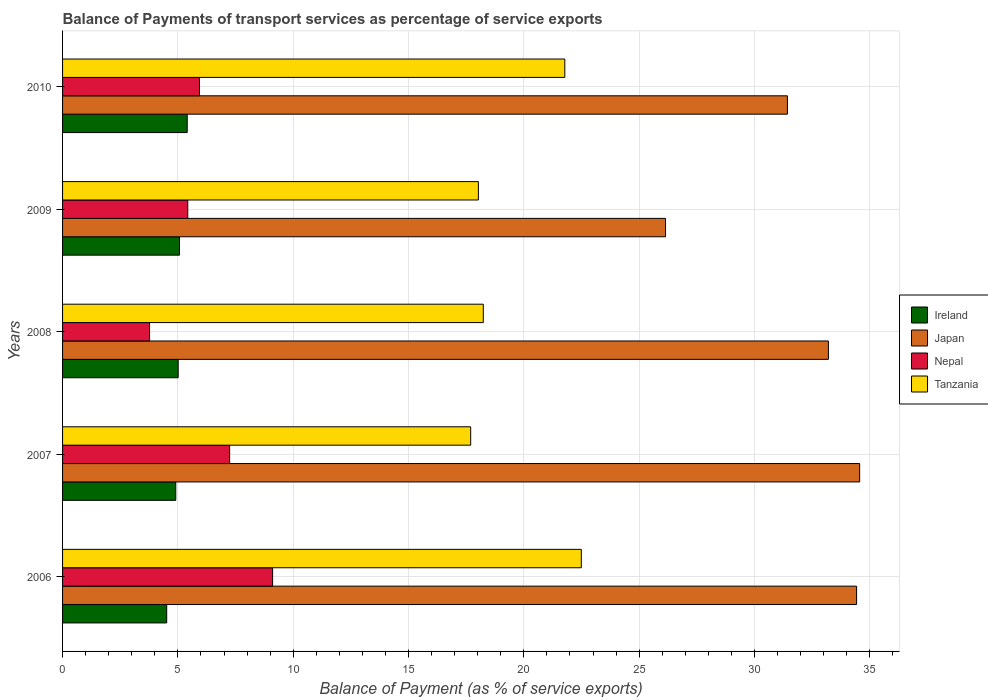How many groups of bars are there?
Make the answer very short. 5. How many bars are there on the 4th tick from the top?
Provide a succinct answer. 4. What is the label of the 1st group of bars from the top?
Ensure brevity in your answer.  2010. In how many cases, is the number of bars for a given year not equal to the number of legend labels?
Your answer should be very brief. 0. What is the balance of payments of transport services in Tanzania in 2010?
Your answer should be very brief. 21.78. Across all years, what is the maximum balance of payments of transport services in Ireland?
Ensure brevity in your answer.  5.4. Across all years, what is the minimum balance of payments of transport services in Ireland?
Your response must be concise. 4.52. In which year was the balance of payments of transport services in Nepal maximum?
Your answer should be compact. 2006. In which year was the balance of payments of transport services in Ireland minimum?
Your answer should be very brief. 2006. What is the total balance of payments of transport services in Ireland in the graph?
Provide a succinct answer. 24.91. What is the difference between the balance of payments of transport services in Ireland in 2007 and that in 2008?
Ensure brevity in your answer.  -0.1. What is the difference between the balance of payments of transport services in Nepal in 2008 and the balance of payments of transport services in Ireland in 2007?
Keep it short and to the point. -1.14. What is the average balance of payments of transport services in Tanzania per year?
Your answer should be compact. 19.65. In the year 2009, what is the difference between the balance of payments of transport services in Ireland and balance of payments of transport services in Tanzania?
Ensure brevity in your answer.  -12.96. In how many years, is the balance of payments of transport services in Japan greater than 13 %?
Keep it short and to the point. 5. What is the ratio of the balance of payments of transport services in Japan in 2006 to that in 2008?
Offer a terse response. 1.04. Is the balance of payments of transport services in Japan in 2007 less than that in 2009?
Make the answer very short. No. What is the difference between the highest and the second highest balance of payments of transport services in Ireland?
Keep it short and to the point. 0.33. What is the difference between the highest and the lowest balance of payments of transport services in Ireland?
Your answer should be very brief. 0.89. In how many years, is the balance of payments of transport services in Japan greater than the average balance of payments of transport services in Japan taken over all years?
Provide a succinct answer. 3. Is it the case that in every year, the sum of the balance of payments of transport services in Nepal and balance of payments of transport services in Japan is greater than the sum of balance of payments of transport services in Tanzania and balance of payments of transport services in Ireland?
Offer a terse response. No. What does the 4th bar from the top in 2007 represents?
Your answer should be compact. Ireland. What does the 2nd bar from the bottom in 2007 represents?
Your answer should be compact. Japan. Is it the case that in every year, the sum of the balance of payments of transport services in Ireland and balance of payments of transport services in Tanzania is greater than the balance of payments of transport services in Nepal?
Keep it short and to the point. Yes. Are all the bars in the graph horizontal?
Offer a very short reply. Yes. How many years are there in the graph?
Keep it short and to the point. 5. Are the values on the major ticks of X-axis written in scientific E-notation?
Offer a very short reply. No. Does the graph contain any zero values?
Your answer should be very brief. No. Does the graph contain grids?
Your answer should be very brief. Yes. Where does the legend appear in the graph?
Your answer should be compact. Center right. How many legend labels are there?
Provide a succinct answer. 4. How are the legend labels stacked?
Keep it short and to the point. Vertical. What is the title of the graph?
Your response must be concise. Balance of Payments of transport services as percentage of service exports. Does "Iraq" appear as one of the legend labels in the graph?
Provide a succinct answer. No. What is the label or title of the X-axis?
Provide a short and direct response. Balance of Payment (as % of service exports). What is the label or title of the Y-axis?
Your answer should be very brief. Years. What is the Balance of Payment (as % of service exports) of Ireland in 2006?
Provide a short and direct response. 4.52. What is the Balance of Payment (as % of service exports) in Japan in 2006?
Keep it short and to the point. 34.43. What is the Balance of Payment (as % of service exports) of Nepal in 2006?
Your response must be concise. 9.11. What is the Balance of Payment (as % of service exports) in Tanzania in 2006?
Your answer should be very brief. 22.49. What is the Balance of Payment (as % of service exports) of Ireland in 2007?
Make the answer very short. 4.91. What is the Balance of Payment (as % of service exports) in Japan in 2007?
Make the answer very short. 34.56. What is the Balance of Payment (as % of service exports) in Nepal in 2007?
Keep it short and to the point. 7.24. What is the Balance of Payment (as % of service exports) in Tanzania in 2007?
Make the answer very short. 17.7. What is the Balance of Payment (as % of service exports) of Ireland in 2008?
Your response must be concise. 5.01. What is the Balance of Payment (as % of service exports) in Japan in 2008?
Your response must be concise. 33.21. What is the Balance of Payment (as % of service exports) in Nepal in 2008?
Your answer should be compact. 3.77. What is the Balance of Payment (as % of service exports) of Tanzania in 2008?
Give a very brief answer. 18.24. What is the Balance of Payment (as % of service exports) of Ireland in 2009?
Your answer should be very brief. 5.07. What is the Balance of Payment (as % of service exports) of Japan in 2009?
Make the answer very short. 26.14. What is the Balance of Payment (as % of service exports) of Nepal in 2009?
Offer a terse response. 5.43. What is the Balance of Payment (as % of service exports) in Tanzania in 2009?
Your answer should be very brief. 18.03. What is the Balance of Payment (as % of service exports) of Ireland in 2010?
Offer a very short reply. 5.4. What is the Balance of Payment (as % of service exports) in Japan in 2010?
Your answer should be compact. 31.43. What is the Balance of Payment (as % of service exports) of Nepal in 2010?
Provide a short and direct response. 5.94. What is the Balance of Payment (as % of service exports) in Tanzania in 2010?
Your answer should be compact. 21.78. Across all years, what is the maximum Balance of Payment (as % of service exports) in Ireland?
Your answer should be compact. 5.4. Across all years, what is the maximum Balance of Payment (as % of service exports) in Japan?
Keep it short and to the point. 34.56. Across all years, what is the maximum Balance of Payment (as % of service exports) of Nepal?
Your response must be concise. 9.11. Across all years, what is the maximum Balance of Payment (as % of service exports) of Tanzania?
Keep it short and to the point. 22.49. Across all years, what is the minimum Balance of Payment (as % of service exports) in Ireland?
Give a very brief answer. 4.52. Across all years, what is the minimum Balance of Payment (as % of service exports) in Japan?
Provide a short and direct response. 26.14. Across all years, what is the minimum Balance of Payment (as % of service exports) in Nepal?
Provide a short and direct response. 3.77. Across all years, what is the minimum Balance of Payment (as % of service exports) in Tanzania?
Provide a short and direct response. 17.7. What is the total Balance of Payment (as % of service exports) in Ireland in the graph?
Offer a terse response. 24.91. What is the total Balance of Payment (as % of service exports) in Japan in the graph?
Offer a terse response. 159.77. What is the total Balance of Payment (as % of service exports) in Nepal in the graph?
Offer a terse response. 31.49. What is the total Balance of Payment (as % of service exports) of Tanzania in the graph?
Offer a terse response. 98.24. What is the difference between the Balance of Payment (as % of service exports) of Ireland in 2006 and that in 2007?
Offer a very short reply. -0.39. What is the difference between the Balance of Payment (as % of service exports) in Japan in 2006 and that in 2007?
Provide a succinct answer. -0.13. What is the difference between the Balance of Payment (as % of service exports) of Nepal in 2006 and that in 2007?
Provide a succinct answer. 1.86. What is the difference between the Balance of Payment (as % of service exports) in Tanzania in 2006 and that in 2007?
Make the answer very short. 4.8. What is the difference between the Balance of Payment (as % of service exports) of Ireland in 2006 and that in 2008?
Your response must be concise. -0.5. What is the difference between the Balance of Payment (as % of service exports) in Japan in 2006 and that in 2008?
Make the answer very short. 1.22. What is the difference between the Balance of Payment (as % of service exports) of Nepal in 2006 and that in 2008?
Give a very brief answer. 5.34. What is the difference between the Balance of Payment (as % of service exports) of Tanzania in 2006 and that in 2008?
Offer a terse response. 4.25. What is the difference between the Balance of Payment (as % of service exports) of Ireland in 2006 and that in 2009?
Give a very brief answer. -0.56. What is the difference between the Balance of Payment (as % of service exports) in Japan in 2006 and that in 2009?
Your answer should be compact. 8.29. What is the difference between the Balance of Payment (as % of service exports) in Nepal in 2006 and that in 2009?
Your response must be concise. 3.68. What is the difference between the Balance of Payment (as % of service exports) of Tanzania in 2006 and that in 2009?
Give a very brief answer. 4.46. What is the difference between the Balance of Payment (as % of service exports) of Ireland in 2006 and that in 2010?
Provide a succinct answer. -0.89. What is the difference between the Balance of Payment (as % of service exports) of Japan in 2006 and that in 2010?
Your answer should be compact. 3. What is the difference between the Balance of Payment (as % of service exports) in Nepal in 2006 and that in 2010?
Provide a succinct answer. 3.17. What is the difference between the Balance of Payment (as % of service exports) in Tanzania in 2006 and that in 2010?
Provide a succinct answer. 0.72. What is the difference between the Balance of Payment (as % of service exports) of Ireland in 2007 and that in 2008?
Your response must be concise. -0.1. What is the difference between the Balance of Payment (as % of service exports) of Japan in 2007 and that in 2008?
Ensure brevity in your answer.  1.36. What is the difference between the Balance of Payment (as % of service exports) of Nepal in 2007 and that in 2008?
Make the answer very short. 3.47. What is the difference between the Balance of Payment (as % of service exports) in Tanzania in 2007 and that in 2008?
Make the answer very short. -0.55. What is the difference between the Balance of Payment (as % of service exports) in Ireland in 2007 and that in 2009?
Offer a very short reply. -0.16. What is the difference between the Balance of Payment (as % of service exports) in Japan in 2007 and that in 2009?
Your response must be concise. 8.42. What is the difference between the Balance of Payment (as % of service exports) of Nepal in 2007 and that in 2009?
Your answer should be very brief. 1.82. What is the difference between the Balance of Payment (as % of service exports) in Tanzania in 2007 and that in 2009?
Provide a short and direct response. -0.33. What is the difference between the Balance of Payment (as % of service exports) of Ireland in 2007 and that in 2010?
Keep it short and to the point. -0.5. What is the difference between the Balance of Payment (as % of service exports) of Japan in 2007 and that in 2010?
Your answer should be compact. 3.13. What is the difference between the Balance of Payment (as % of service exports) of Nepal in 2007 and that in 2010?
Provide a succinct answer. 1.31. What is the difference between the Balance of Payment (as % of service exports) of Tanzania in 2007 and that in 2010?
Provide a short and direct response. -4.08. What is the difference between the Balance of Payment (as % of service exports) in Ireland in 2008 and that in 2009?
Keep it short and to the point. -0.06. What is the difference between the Balance of Payment (as % of service exports) of Japan in 2008 and that in 2009?
Offer a very short reply. 7.06. What is the difference between the Balance of Payment (as % of service exports) of Nepal in 2008 and that in 2009?
Give a very brief answer. -1.66. What is the difference between the Balance of Payment (as % of service exports) in Tanzania in 2008 and that in 2009?
Ensure brevity in your answer.  0.21. What is the difference between the Balance of Payment (as % of service exports) of Ireland in 2008 and that in 2010?
Offer a terse response. -0.39. What is the difference between the Balance of Payment (as % of service exports) in Japan in 2008 and that in 2010?
Your answer should be compact. 1.78. What is the difference between the Balance of Payment (as % of service exports) in Nepal in 2008 and that in 2010?
Your answer should be very brief. -2.16. What is the difference between the Balance of Payment (as % of service exports) in Tanzania in 2008 and that in 2010?
Your answer should be very brief. -3.53. What is the difference between the Balance of Payment (as % of service exports) of Ireland in 2009 and that in 2010?
Your answer should be very brief. -0.33. What is the difference between the Balance of Payment (as % of service exports) of Japan in 2009 and that in 2010?
Keep it short and to the point. -5.29. What is the difference between the Balance of Payment (as % of service exports) of Nepal in 2009 and that in 2010?
Make the answer very short. -0.51. What is the difference between the Balance of Payment (as % of service exports) in Tanzania in 2009 and that in 2010?
Provide a succinct answer. -3.75. What is the difference between the Balance of Payment (as % of service exports) in Ireland in 2006 and the Balance of Payment (as % of service exports) in Japan in 2007?
Your answer should be very brief. -30.05. What is the difference between the Balance of Payment (as % of service exports) in Ireland in 2006 and the Balance of Payment (as % of service exports) in Nepal in 2007?
Give a very brief answer. -2.73. What is the difference between the Balance of Payment (as % of service exports) of Ireland in 2006 and the Balance of Payment (as % of service exports) of Tanzania in 2007?
Your answer should be compact. -13.18. What is the difference between the Balance of Payment (as % of service exports) of Japan in 2006 and the Balance of Payment (as % of service exports) of Nepal in 2007?
Make the answer very short. 27.19. What is the difference between the Balance of Payment (as % of service exports) of Japan in 2006 and the Balance of Payment (as % of service exports) of Tanzania in 2007?
Offer a very short reply. 16.73. What is the difference between the Balance of Payment (as % of service exports) in Nepal in 2006 and the Balance of Payment (as % of service exports) in Tanzania in 2007?
Offer a very short reply. -8.59. What is the difference between the Balance of Payment (as % of service exports) of Ireland in 2006 and the Balance of Payment (as % of service exports) of Japan in 2008?
Offer a terse response. -28.69. What is the difference between the Balance of Payment (as % of service exports) in Ireland in 2006 and the Balance of Payment (as % of service exports) in Nepal in 2008?
Ensure brevity in your answer.  0.74. What is the difference between the Balance of Payment (as % of service exports) in Ireland in 2006 and the Balance of Payment (as % of service exports) in Tanzania in 2008?
Ensure brevity in your answer.  -13.73. What is the difference between the Balance of Payment (as % of service exports) in Japan in 2006 and the Balance of Payment (as % of service exports) in Nepal in 2008?
Keep it short and to the point. 30.66. What is the difference between the Balance of Payment (as % of service exports) of Japan in 2006 and the Balance of Payment (as % of service exports) of Tanzania in 2008?
Make the answer very short. 16.19. What is the difference between the Balance of Payment (as % of service exports) in Nepal in 2006 and the Balance of Payment (as % of service exports) in Tanzania in 2008?
Your answer should be very brief. -9.13. What is the difference between the Balance of Payment (as % of service exports) in Ireland in 2006 and the Balance of Payment (as % of service exports) in Japan in 2009?
Keep it short and to the point. -21.63. What is the difference between the Balance of Payment (as % of service exports) of Ireland in 2006 and the Balance of Payment (as % of service exports) of Nepal in 2009?
Your answer should be compact. -0.91. What is the difference between the Balance of Payment (as % of service exports) in Ireland in 2006 and the Balance of Payment (as % of service exports) in Tanzania in 2009?
Keep it short and to the point. -13.52. What is the difference between the Balance of Payment (as % of service exports) in Japan in 2006 and the Balance of Payment (as % of service exports) in Nepal in 2009?
Make the answer very short. 29. What is the difference between the Balance of Payment (as % of service exports) in Japan in 2006 and the Balance of Payment (as % of service exports) in Tanzania in 2009?
Give a very brief answer. 16.4. What is the difference between the Balance of Payment (as % of service exports) in Nepal in 2006 and the Balance of Payment (as % of service exports) in Tanzania in 2009?
Ensure brevity in your answer.  -8.92. What is the difference between the Balance of Payment (as % of service exports) of Ireland in 2006 and the Balance of Payment (as % of service exports) of Japan in 2010?
Offer a very short reply. -26.92. What is the difference between the Balance of Payment (as % of service exports) in Ireland in 2006 and the Balance of Payment (as % of service exports) in Nepal in 2010?
Ensure brevity in your answer.  -1.42. What is the difference between the Balance of Payment (as % of service exports) in Ireland in 2006 and the Balance of Payment (as % of service exports) in Tanzania in 2010?
Give a very brief answer. -17.26. What is the difference between the Balance of Payment (as % of service exports) of Japan in 2006 and the Balance of Payment (as % of service exports) of Nepal in 2010?
Ensure brevity in your answer.  28.49. What is the difference between the Balance of Payment (as % of service exports) of Japan in 2006 and the Balance of Payment (as % of service exports) of Tanzania in 2010?
Provide a short and direct response. 12.65. What is the difference between the Balance of Payment (as % of service exports) of Nepal in 2006 and the Balance of Payment (as % of service exports) of Tanzania in 2010?
Your answer should be compact. -12.67. What is the difference between the Balance of Payment (as % of service exports) in Ireland in 2007 and the Balance of Payment (as % of service exports) in Japan in 2008?
Offer a very short reply. -28.3. What is the difference between the Balance of Payment (as % of service exports) of Ireland in 2007 and the Balance of Payment (as % of service exports) of Nepal in 2008?
Offer a very short reply. 1.14. What is the difference between the Balance of Payment (as % of service exports) of Ireland in 2007 and the Balance of Payment (as % of service exports) of Tanzania in 2008?
Your answer should be compact. -13.33. What is the difference between the Balance of Payment (as % of service exports) in Japan in 2007 and the Balance of Payment (as % of service exports) in Nepal in 2008?
Your response must be concise. 30.79. What is the difference between the Balance of Payment (as % of service exports) in Japan in 2007 and the Balance of Payment (as % of service exports) in Tanzania in 2008?
Offer a very short reply. 16.32. What is the difference between the Balance of Payment (as % of service exports) in Nepal in 2007 and the Balance of Payment (as % of service exports) in Tanzania in 2008?
Offer a terse response. -11. What is the difference between the Balance of Payment (as % of service exports) in Ireland in 2007 and the Balance of Payment (as % of service exports) in Japan in 2009?
Offer a terse response. -21.24. What is the difference between the Balance of Payment (as % of service exports) of Ireland in 2007 and the Balance of Payment (as % of service exports) of Nepal in 2009?
Give a very brief answer. -0.52. What is the difference between the Balance of Payment (as % of service exports) in Ireland in 2007 and the Balance of Payment (as % of service exports) in Tanzania in 2009?
Make the answer very short. -13.12. What is the difference between the Balance of Payment (as % of service exports) in Japan in 2007 and the Balance of Payment (as % of service exports) in Nepal in 2009?
Give a very brief answer. 29.13. What is the difference between the Balance of Payment (as % of service exports) in Japan in 2007 and the Balance of Payment (as % of service exports) in Tanzania in 2009?
Provide a short and direct response. 16.53. What is the difference between the Balance of Payment (as % of service exports) of Nepal in 2007 and the Balance of Payment (as % of service exports) of Tanzania in 2009?
Provide a short and direct response. -10.79. What is the difference between the Balance of Payment (as % of service exports) in Ireland in 2007 and the Balance of Payment (as % of service exports) in Japan in 2010?
Ensure brevity in your answer.  -26.52. What is the difference between the Balance of Payment (as % of service exports) of Ireland in 2007 and the Balance of Payment (as % of service exports) of Nepal in 2010?
Offer a terse response. -1.03. What is the difference between the Balance of Payment (as % of service exports) of Ireland in 2007 and the Balance of Payment (as % of service exports) of Tanzania in 2010?
Make the answer very short. -16.87. What is the difference between the Balance of Payment (as % of service exports) in Japan in 2007 and the Balance of Payment (as % of service exports) in Nepal in 2010?
Your answer should be compact. 28.63. What is the difference between the Balance of Payment (as % of service exports) of Japan in 2007 and the Balance of Payment (as % of service exports) of Tanzania in 2010?
Your response must be concise. 12.78. What is the difference between the Balance of Payment (as % of service exports) of Nepal in 2007 and the Balance of Payment (as % of service exports) of Tanzania in 2010?
Your response must be concise. -14.53. What is the difference between the Balance of Payment (as % of service exports) in Ireland in 2008 and the Balance of Payment (as % of service exports) in Japan in 2009?
Your answer should be very brief. -21.13. What is the difference between the Balance of Payment (as % of service exports) of Ireland in 2008 and the Balance of Payment (as % of service exports) of Nepal in 2009?
Your answer should be very brief. -0.42. What is the difference between the Balance of Payment (as % of service exports) of Ireland in 2008 and the Balance of Payment (as % of service exports) of Tanzania in 2009?
Provide a short and direct response. -13.02. What is the difference between the Balance of Payment (as % of service exports) in Japan in 2008 and the Balance of Payment (as % of service exports) in Nepal in 2009?
Your answer should be very brief. 27.78. What is the difference between the Balance of Payment (as % of service exports) in Japan in 2008 and the Balance of Payment (as % of service exports) in Tanzania in 2009?
Ensure brevity in your answer.  15.18. What is the difference between the Balance of Payment (as % of service exports) of Nepal in 2008 and the Balance of Payment (as % of service exports) of Tanzania in 2009?
Make the answer very short. -14.26. What is the difference between the Balance of Payment (as % of service exports) in Ireland in 2008 and the Balance of Payment (as % of service exports) in Japan in 2010?
Offer a very short reply. -26.42. What is the difference between the Balance of Payment (as % of service exports) in Ireland in 2008 and the Balance of Payment (as % of service exports) in Nepal in 2010?
Ensure brevity in your answer.  -0.92. What is the difference between the Balance of Payment (as % of service exports) of Ireland in 2008 and the Balance of Payment (as % of service exports) of Tanzania in 2010?
Ensure brevity in your answer.  -16.77. What is the difference between the Balance of Payment (as % of service exports) of Japan in 2008 and the Balance of Payment (as % of service exports) of Nepal in 2010?
Keep it short and to the point. 27.27. What is the difference between the Balance of Payment (as % of service exports) of Japan in 2008 and the Balance of Payment (as % of service exports) of Tanzania in 2010?
Provide a succinct answer. 11.43. What is the difference between the Balance of Payment (as % of service exports) of Nepal in 2008 and the Balance of Payment (as % of service exports) of Tanzania in 2010?
Make the answer very short. -18.01. What is the difference between the Balance of Payment (as % of service exports) in Ireland in 2009 and the Balance of Payment (as % of service exports) in Japan in 2010?
Give a very brief answer. -26.36. What is the difference between the Balance of Payment (as % of service exports) of Ireland in 2009 and the Balance of Payment (as % of service exports) of Nepal in 2010?
Ensure brevity in your answer.  -0.87. What is the difference between the Balance of Payment (as % of service exports) in Ireland in 2009 and the Balance of Payment (as % of service exports) in Tanzania in 2010?
Your response must be concise. -16.71. What is the difference between the Balance of Payment (as % of service exports) in Japan in 2009 and the Balance of Payment (as % of service exports) in Nepal in 2010?
Offer a terse response. 20.21. What is the difference between the Balance of Payment (as % of service exports) of Japan in 2009 and the Balance of Payment (as % of service exports) of Tanzania in 2010?
Your answer should be very brief. 4.37. What is the difference between the Balance of Payment (as % of service exports) in Nepal in 2009 and the Balance of Payment (as % of service exports) in Tanzania in 2010?
Your answer should be very brief. -16.35. What is the average Balance of Payment (as % of service exports) of Ireland per year?
Your response must be concise. 4.98. What is the average Balance of Payment (as % of service exports) of Japan per year?
Make the answer very short. 31.95. What is the average Balance of Payment (as % of service exports) of Nepal per year?
Make the answer very short. 6.3. What is the average Balance of Payment (as % of service exports) of Tanzania per year?
Provide a succinct answer. 19.65. In the year 2006, what is the difference between the Balance of Payment (as % of service exports) in Ireland and Balance of Payment (as % of service exports) in Japan?
Your answer should be compact. -29.91. In the year 2006, what is the difference between the Balance of Payment (as % of service exports) in Ireland and Balance of Payment (as % of service exports) in Nepal?
Your answer should be compact. -4.59. In the year 2006, what is the difference between the Balance of Payment (as % of service exports) in Ireland and Balance of Payment (as % of service exports) in Tanzania?
Give a very brief answer. -17.98. In the year 2006, what is the difference between the Balance of Payment (as % of service exports) of Japan and Balance of Payment (as % of service exports) of Nepal?
Offer a terse response. 25.32. In the year 2006, what is the difference between the Balance of Payment (as % of service exports) of Japan and Balance of Payment (as % of service exports) of Tanzania?
Offer a very short reply. 11.94. In the year 2006, what is the difference between the Balance of Payment (as % of service exports) in Nepal and Balance of Payment (as % of service exports) in Tanzania?
Your response must be concise. -13.39. In the year 2007, what is the difference between the Balance of Payment (as % of service exports) of Ireland and Balance of Payment (as % of service exports) of Japan?
Your answer should be very brief. -29.65. In the year 2007, what is the difference between the Balance of Payment (as % of service exports) of Ireland and Balance of Payment (as % of service exports) of Nepal?
Your answer should be very brief. -2.34. In the year 2007, what is the difference between the Balance of Payment (as % of service exports) of Ireland and Balance of Payment (as % of service exports) of Tanzania?
Offer a very short reply. -12.79. In the year 2007, what is the difference between the Balance of Payment (as % of service exports) in Japan and Balance of Payment (as % of service exports) in Nepal?
Offer a terse response. 27.32. In the year 2007, what is the difference between the Balance of Payment (as % of service exports) of Japan and Balance of Payment (as % of service exports) of Tanzania?
Ensure brevity in your answer.  16.87. In the year 2007, what is the difference between the Balance of Payment (as % of service exports) in Nepal and Balance of Payment (as % of service exports) in Tanzania?
Provide a succinct answer. -10.45. In the year 2008, what is the difference between the Balance of Payment (as % of service exports) in Ireland and Balance of Payment (as % of service exports) in Japan?
Provide a succinct answer. -28.19. In the year 2008, what is the difference between the Balance of Payment (as % of service exports) of Ireland and Balance of Payment (as % of service exports) of Nepal?
Provide a short and direct response. 1.24. In the year 2008, what is the difference between the Balance of Payment (as % of service exports) of Ireland and Balance of Payment (as % of service exports) of Tanzania?
Offer a very short reply. -13.23. In the year 2008, what is the difference between the Balance of Payment (as % of service exports) in Japan and Balance of Payment (as % of service exports) in Nepal?
Keep it short and to the point. 29.43. In the year 2008, what is the difference between the Balance of Payment (as % of service exports) of Japan and Balance of Payment (as % of service exports) of Tanzania?
Your answer should be very brief. 14.96. In the year 2008, what is the difference between the Balance of Payment (as % of service exports) of Nepal and Balance of Payment (as % of service exports) of Tanzania?
Offer a terse response. -14.47. In the year 2009, what is the difference between the Balance of Payment (as % of service exports) of Ireland and Balance of Payment (as % of service exports) of Japan?
Offer a very short reply. -21.07. In the year 2009, what is the difference between the Balance of Payment (as % of service exports) in Ireland and Balance of Payment (as % of service exports) in Nepal?
Offer a very short reply. -0.36. In the year 2009, what is the difference between the Balance of Payment (as % of service exports) in Ireland and Balance of Payment (as % of service exports) in Tanzania?
Give a very brief answer. -12.96. In the year 2009, what is the difference between the Balance of Payment (as % of service exports) in Japan and Balance of Payment (as % of service exports) in Nepal?
Keep it short and to the point. 20.72. In the year 2009, what is the difference between the Balance of Payment (as % of service exports) in Japan and Balance of Payment (as % of service exports) in Tanzania?
Your response must be concise. 8.11. In the year 2009, what is the difference between the Balance of Payment (as % of service exports) of Nepal and Balance of Payment (as % of service exports) of Tanzania?
Provide a succinct answer. -12.6. In the year 2010, what is the difference between the Balance of Payment (as % of service exports) in Ireland and Balance of Payment (as % of service exports) in Japan?
Your answer should be very brief. -26.03. In the year 2010, what is the difference between the Balance of Payment (as % of service exports) of Ireland and Balance of Payment (as % of service exports) of Nepal?
Offer a terse response. -0.53. In the year 2010, what is the difference between the Balance of Payment (as % of service exports) of Ireland and Balance of Payment (as % of service exports) of Tanzania?
Provide a short and direct response. -16.37. In the year 2010, what is the difference between the Balance of Payment (as % of service exports) in Japan and Balance of Payment (as % of service exports) in Nepal?
Your response must be concise. 25.49. In the year 2010, what is the difference between the Balance of Payment (as % of service exports) in Japan and Balance of Payment (as % of service exports) in Tanzania?
Provide a succinct answer. 9.65. In the year 2010, what is the difference between the Balance of Payment (as % of service exports) in Nepal and Balance of Payment (as % of service exports) in Tanzania?
Your response must be concise. -15.84. What is the ratio of the Balance of Payment (as % of service exports) in Ireland in 2006 to that in 2007?
Your answer should be very brief. 0.92. What is the ratio of the Balance of Payment (as % of service exports) of Japan in 2006 to that in 2007?
Your answer should be compact. 1. What is the ratio of the Balance of Payment (as % of service exports) of Nepal in 2006 to that in 2007?
Keep it short and to the point. 1.26. What is the ratio of the Balance of Payment (as % of service exports) in Tanzania in 2006 to that in 2007?
Make the answer very short. 1.27. What is the ratio of the Balance of Payment (as % of service exports) in Ireland in 2006 to that in 2008?
Offer a very short reply. 0.9. What is the ratio of the Balance of Payment (as % of service exports) of Japan in 2006 to that in 2008?
Offer a very short reply. 1.04. What is the ratio of the Balance of Payment (as % of service exports) in Nepal in 2006 to that in 2008?
Ensure brevity in your answer.  2.41. What is the ratio of the Balance of Payment (as % of service exports) of Tanzania in 2006 to that in 2008?
Give a very brief answer. 1.23. What is the ratio of the Balance of Payment (as % of service exports) in Ireland in 2006 to that in 2009?
Provide a short and direct response. 0.89. What is the ratio of the Balance of Payment (as % of service exports) of Japan in 2006 to that in 2009?
Your answer should be compact. 1.32. What is the ratio of the Balance of Payment (as % of service exports) in Nepal in 2006 to that in 2009?
Your response must be concise. 1.68. What is the ratio of the Balance of Payment (as % of service exports) of Tanzania in 2006 to that in 2009?
Your answer should be very brief. 1.25. What is the ratio of the Balance of Payment (as % of service exports) in Ireland in 2006 to that in 2010?
Provide a succinct answer. 0.84. What is the ratio of the Balance of Payment (as % of service exports) of Japan in 2006 to that in 2010?
Your answer should be compact. 1.1. What is the ratio of the Balance of Payment (as % of service exports) of Nepal in 2006 to that in 2010?
Keep it short and to the point. 1.53. What is the ratio of the Balance of Payment (as % of service exports) of Tanzania in 2006 to that in 2010?
Your answer should be compact. 1.03. What is the ratio of the Balance of Payment (as % of service exports) of Ireland in 2007 to that in 2008?
Your answer should be very brief. 0.98. What is the ratio of the Balance of Payment (as % of service exports) in Japan in 2007 to that in 2008?
Your response must be concise. 1.04. What is the ratio of the Balance of Payment (as % of service exports) of Nepal in 2007 to that in 2008?
Give a very brief answer. 1.92. What is the ratio of the Balance of Payment (as % of service exports) in Tanzania in 2007 to that in 2008?
Give a very brief answer. 0.97. What is the ratio of the Balance of Payment (as % of service exports) of Japan in 2007 to that in 2009?
Your answer should be compact. 1.32. What is the ratio of the Balance of Payment (as % of service exports) in Nepal in 2007 to that in 2009?
Make the answer very short. 1.33. What is the ratio of the Balance of Payment (as % of service exports) in Tanzania in 2007 to that in 2009?
Provide a succinct answer. 0.98. What is the ratio of the Balance of Payment (as % of service exports) in Ireland in 2007 to that in 2010?
Keep it short and to the point. 0.91. What is the ratio of the Balance of Payment (as % of service exports) in Japan in 2007 to that in 2010?
Provide a short and direct response. 1.1. What is the ratio of the Balance of Payment (as % of service exports) in Nepal in 2007 to that in 2010?
Provide a short and direct response. 1.22. What is the ratio of the Balance of Payment (as % of service exports) of Tanzania in 2007 to that in 2010?
Offer a very short reply. 0.81. What is the ratio of the Balance of Payment (as % of service exports) of Ireland in 2008 to that in 2009?
Your answer should be compact. 0.99. What is the ratio of the Balance of Payment (as % of service exports) of Japan in 2008 to that in 2009?
Offer a very short reply. 1.27. What is the ratio of the Balance of Payment (as % of service exports) of Nepal in 2008 to that in 2009?
Give a very brief answer. 0.69. What is the ratio of the Balance of Payment (as % of service exports) of Tanzania in 2008 to that in 2009?
Keep it short and to the point. 1.01. What is the ratio of the Balance of Payment (as % of service exports) in Ireland in 2008 to that in 2010?
Make the answer very short. 0.93. What is the ratio of the Balance of Payment (as % of service exports) of Japan in 2008 to that in 2010?
Ensure brevity in your answer.  1.06. What is the ratio of the Balance of Payment (as % of service exports) in Nepal in 2008 to that in 2010?
Give a very brief answer. 0.64. What is the ratio of the Balance of Payment (as % of service exports) of Tanzania in 2008 to that in 2010?
Keep it short and to the point. 0.84. What is the ratio of the Balance of Payment (as % of service exports) of Ireland in 2009 to that in 2010?
Provide a short and direct response. 0.94. What is the ratio of the Balance of Payment (as % of service exports) of Japan in 2009 to that in 2010?
Your answer should be compact. 0.83. What is the ratio of the Balance of Payment (as % of service exports) of Nepal in 2009 to that in 2010?
Keep it short and to the point. 0.91. What is the ratio of the Balance of Payment (as % of service exports) of Tanzania in 2009 to that in 2010?
Provide a short and direct response. 0.83. What is the difference between the highest and the second highest Balance of Payment (as % of service exports) of Ireland?
Offer a very short reply. 0.33. What is the difference between the highest and the second highest Balance of Payment (as % of service exports) in Japan?
Your answer should be compact. 0.13. What is the difference between the highest and the second highest Balance of Payment (as % of service exports) in Nepal?
Provide a succinct answer. 1.86. What is the difference between the highest and the second highest Balance of Payment (as % of service exports) of Tanzania?
Offer a terse response. 0.72. What is the difference between the highest and the lowest Balance of Payment (as % of service exports) of Ireland?
Make the answer very short. 0.89. What is the difference between the highest and the lowest Balance of Payment (as % of service exports) of Japan?
Offer a very short reply. 8.42. What is the difference between the highest and the lowest Balance of Payment (as % of service exports) in Nepal?
Provide a short and direct response. 5.34. What is the difference between the highest and the lowest Balance of Payment (as % of service exports) in Tanzania?
Ensure brevity in your answer.  4.8. 